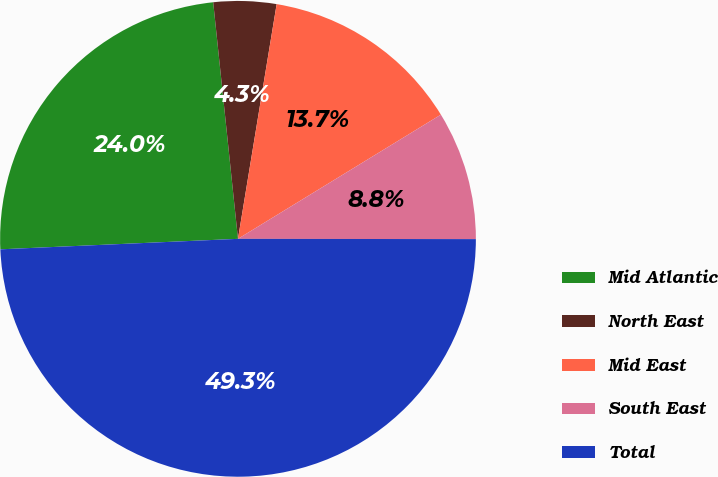<chart> <loc_0><loc_0><loc_500><loc_500><pie_chart><fcel>Mid Atlantic<fcel>North East<fcel>Mid East<fcel>South East<fcel>Total<nl><fcel>24.04%<fcel>4.26%<fcel>13.66%<fcel>8.76%<fcel>49.28%<nl></chart> 